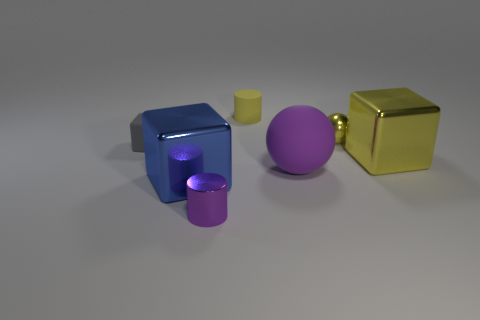Add 1 small gray matte objects. How many objects exist? 8 Subtract all purple cylinders. How many cylinders are left? 1 Subtract all yellow cubes. How many cubes are left? 2 Subtract all green cylinders. How many yellow cubes are left? 1 Subtract all metallic cylinders. Subtract all small blue metal cubes. How many objects are left? 6 Add 5 gray rubber cubes. How many gray rubber cubes are left? 6 Add 7 tiny red rubber objects. How many tiny red rubber objects exist? 7 Subtract 0 green blocks. How many objects are left? 7 Subtract all cylinders. How many objects are left? 5 Subtract 2 cubes. How many cubes are left? 1 